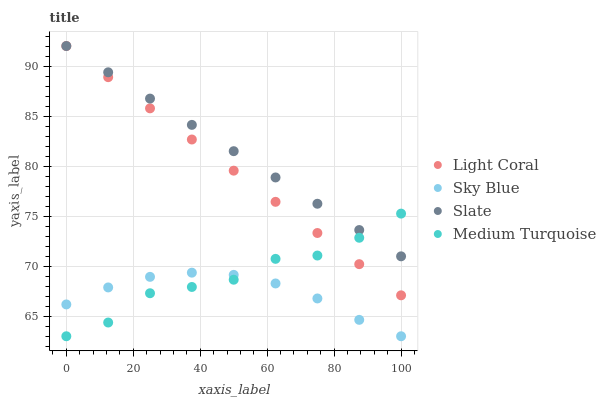Does Sky Blue have the minimum area under the curve?
Answer yes or no. Yes. Does Slate have the maximum area under the curve?
Answer yes or no. Yes. Does Slate have the minimum area under the curve?
Answer yes or no. No. Does Sky Blue have the maximum area under the curve?
Answer yes or no. No. Is Slate the smoothest?
Answer yes or no. Yes. Is Medium Turquoise the roughest?
Answer yes or no. Yes. Is Sky Blue the smoothest?
Answer yes or no. No. Is Sky Blue the roughest?
Answer yes or no. No. Does Sky Blue have the lowest value?
Answer yes or no. Yes. Does Slate have the lowest value?
Answer yes or no. No. Does Slate have the highest value?
Answer yes or no. Yes. Does Sky Blue have the highest value?
Answer yes or no. No. Is Sky Blue less than Slate?
Answer yes or no. Yes. Is Slate greater than Sky Blue?
Answer yes or no. Yes. Does Slate intersect Medium Turquoise?
Answer yes or no. Yes. Is Slate less than Medium Turquoise?
Answer yes or no. No. Is Slate greater than Medium Turquoise?
Answer yes or no. No. Does Sky Blue intersect Slate?
Answer yes or no. No. 